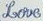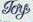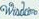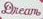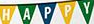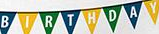Read the text content from these images in order, separated by a semicolon. Love; Toy; ####; Dream; HAPPY; BIRTHDAY 